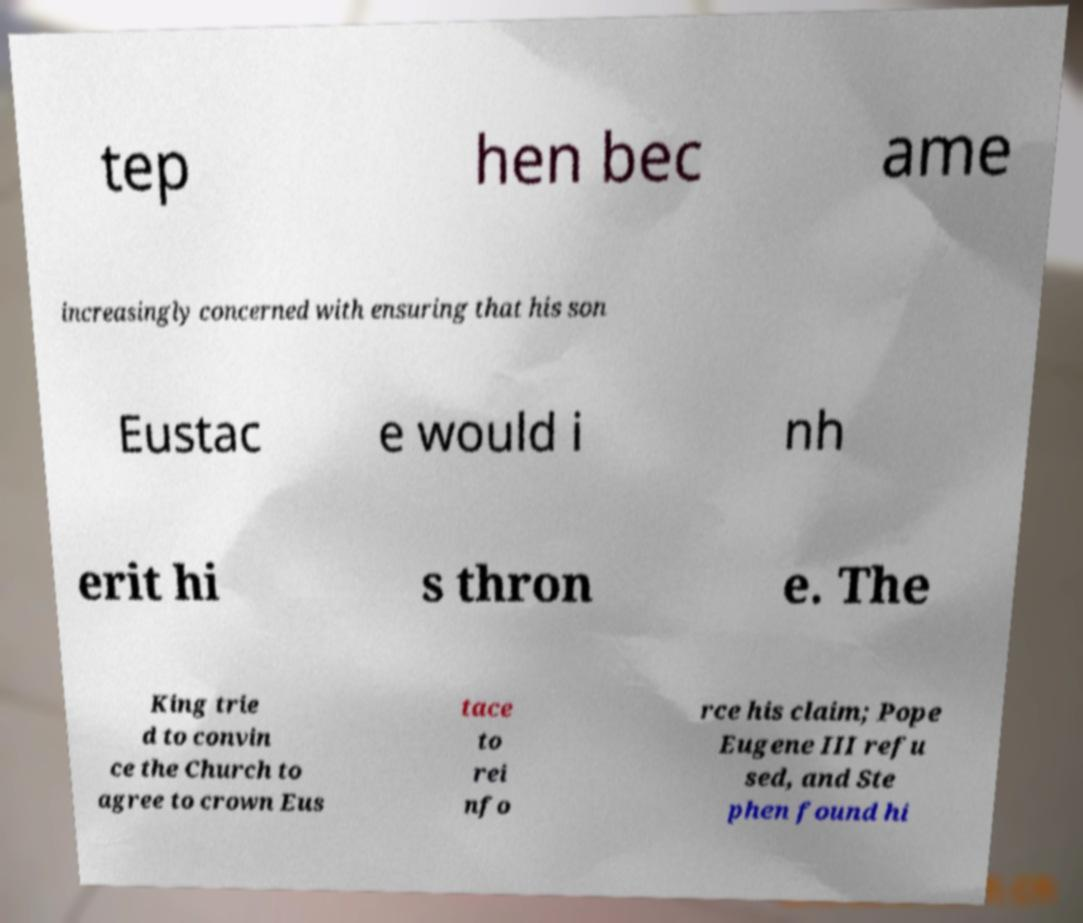For documentation purposes, I need the text within this image transcribed. Could you provide that? tep hen bec ame increasingly concerned with ensuring that his son Eustac e would i nh erit hi s thron e. The King trie d to convin ce the Church to agree to crown Eus tace to rei nfo rce his claim; Pope Eugene III refu sed, and Ste phen found hi 